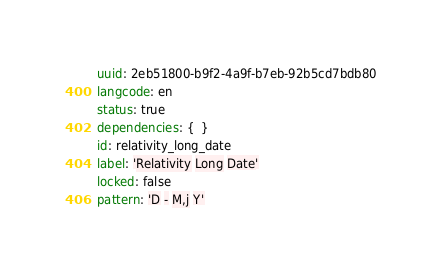<code> <loc_0><loc_0><loc_500><loc_500><_YAML_>uuid: 2eb51800-b9f2-4a9f-b7eb-92b5cd7bdb80
langcode: en
status: true
dependencies: {  }
id: relativity_long_date
label: 'Relativity Long Date'
locked: false
pattern: 'D - M,j Y'
</code> 